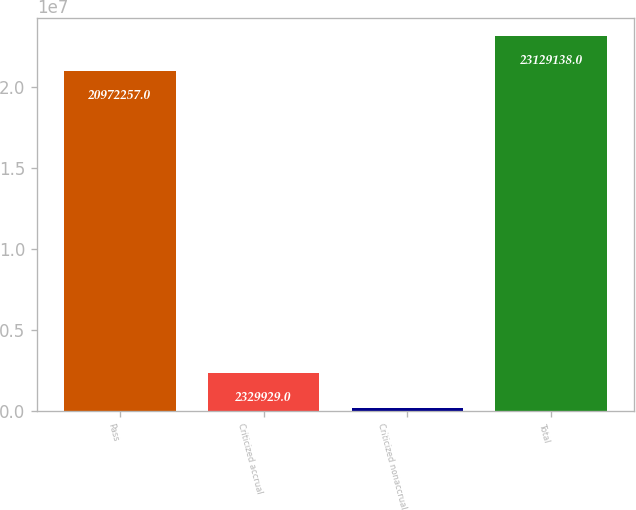Convert chart to OTSL. <chart><loc_0><loc_0><loc_500><loc_500><bar_chart><fcel>Pass<fcel>Criticized accrual<fcel>Criticized nonaccrual<fcel>Total<nl><fcel>2.09723e+07<fcel>2.32993e+06<fcel>173048<fcel>2.31291e+07<nl></chart> 